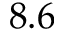<formula> <loc_0><loc_0><loc_500><loc_500>8 . 6</formula> 